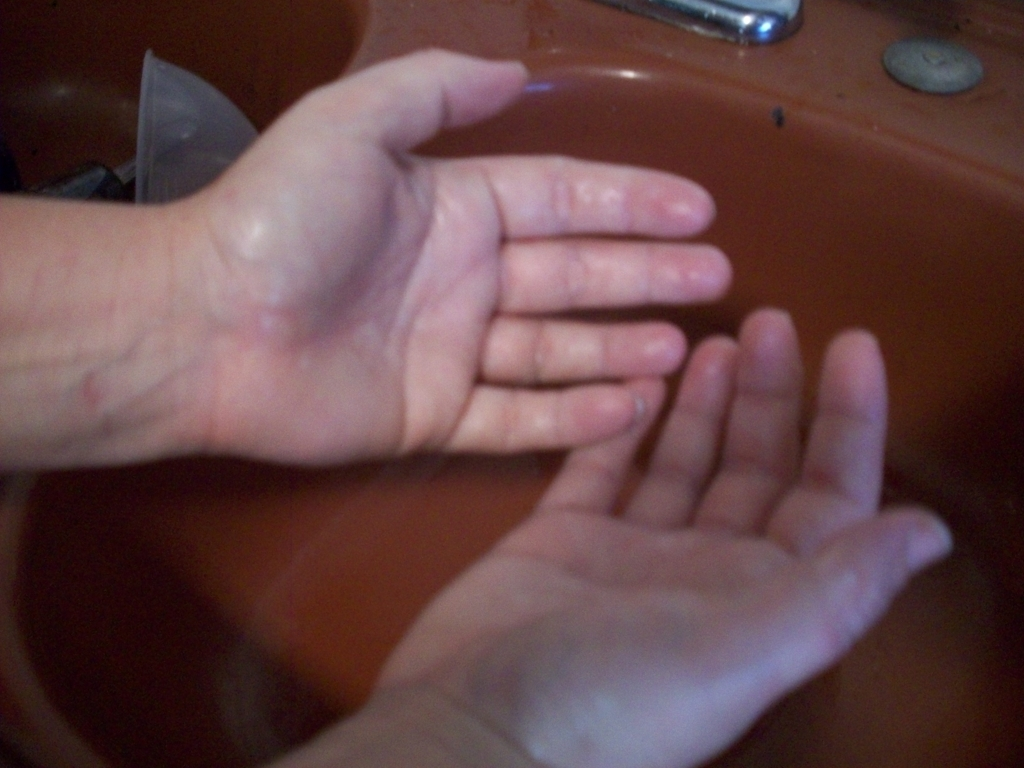Can you describe the technique of the hand wash shown in the image? While it's difficult to determine the exact technique from a still image, the hands seem to be positioned in a way that suggests they could be rubbing together, a key part of effective hand washing to ensure all surfaces are cleaned. Is there anything indicative of the duration of the handwashing? Without video or additional context, it is impossible to assess the duration of the hand washing from a single image. 